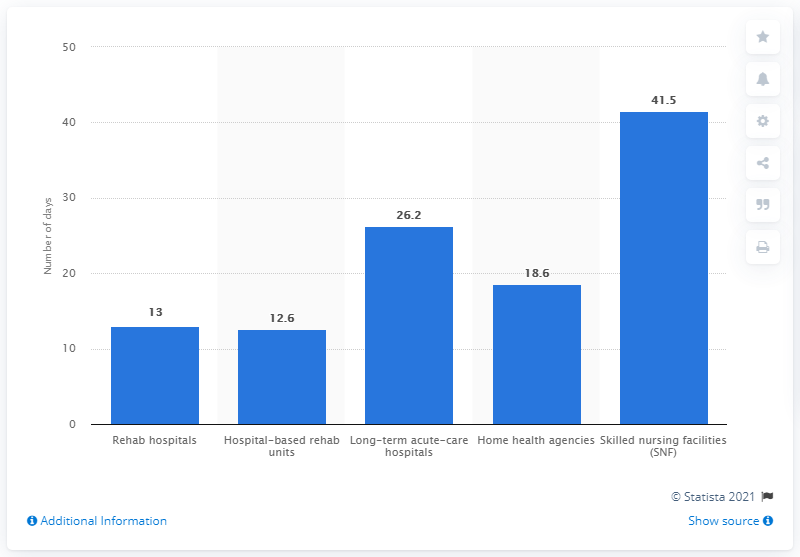Indicate a few pertinent items in this graphic. In the fiscal year 2012, Medicare recipients spent an average of 26.2 days in long-term acute-care hospitals. In fiscal year 2012, Medicare recipients spent an average of 41.5 days in skilled nursing facilities. 